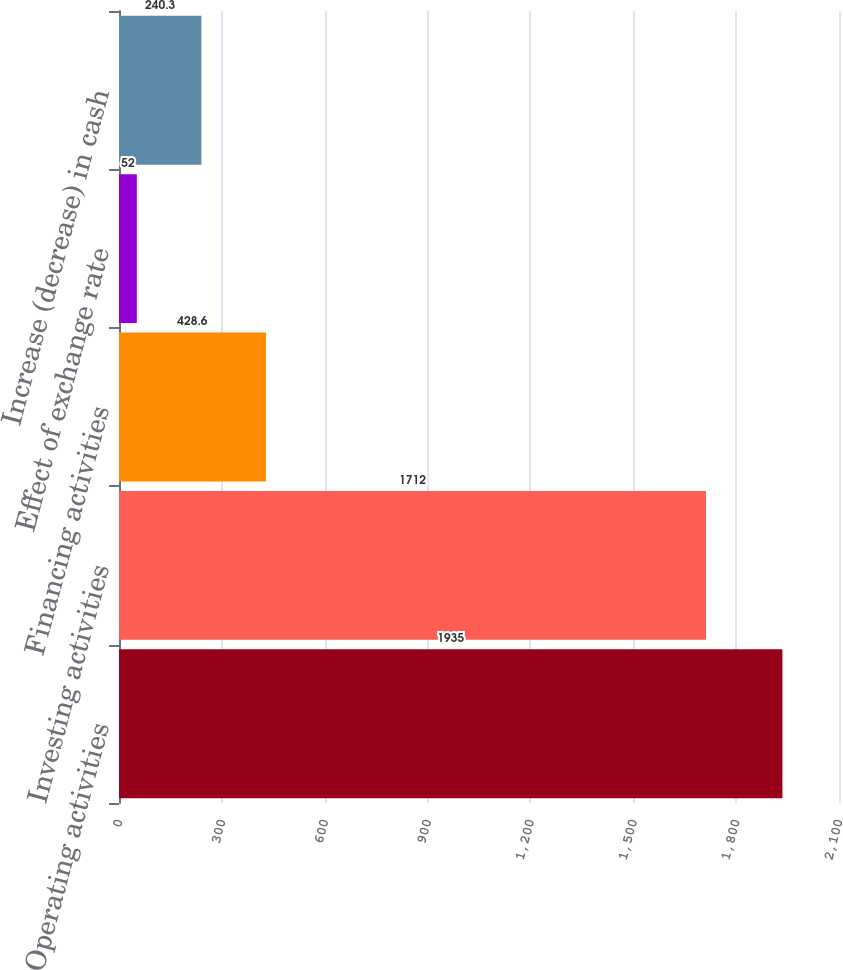<chart> <loc_0><loc_0><loc_500><loc_500><bar_chart><fcel>Operating activities<fcel>Investing activities<fcel>Financing activities<fcel>Effect of exchange rate<fcel>Increase (decrease) in cash<nl><fcel>1935<fcel>1712<fcel>428.6<fcel>52<fcel>240.3<nl></chart> 